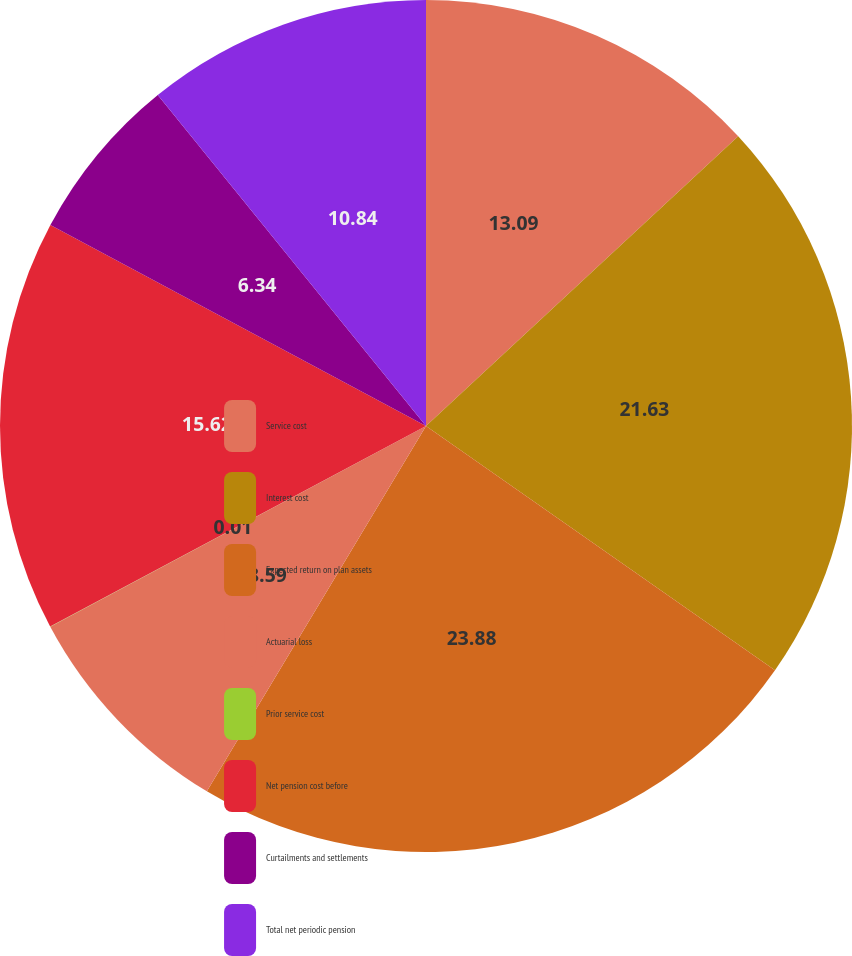Convert chart to OTSL. <chart><loc_0><loc_0><loc_500><loc_500><pie_chart><fcel>Service cost<fcel>Interest cost<fcel>Expected return on plan assets<fcel>Actuarial loss<fcel>Prior service cost<fcel>Net pension cost before<fcel>Curtailments and settlements<fcel>Total net periodic pension<nl><fcel>13.09%<fcel>21.63%<fcel>23.88%<fcel>8.59%<fcel>0.01%<fcel>15.62%<fcel>6.34%<fcel>10.84%<nl></chart> 